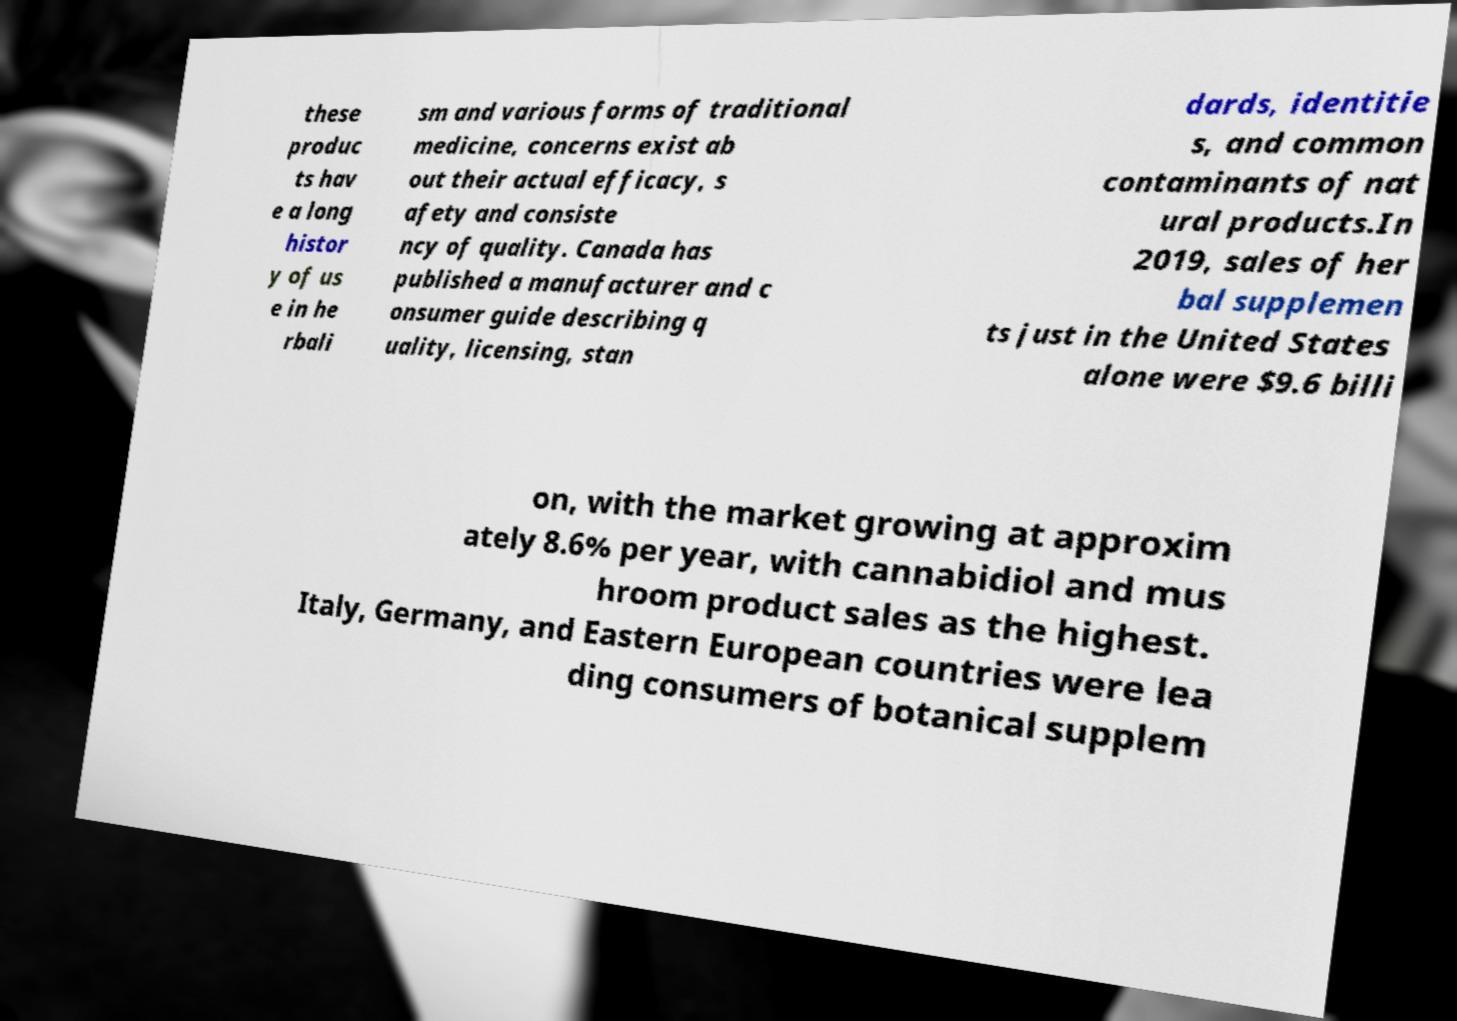What messages or text are displayed in this image? I need them in a readable, typed format. these produc ts hav e a long histor y of us e in he rbali sm and various forms of traditional medicine, concerns exist ab out their actual efficacy, s afety and consiste ncy of quality. Canada has published a manufacturer and c onsumer guide describing q uality, licensing, stan dards, identitie s, and common contaminants of nat ural products.In 2019, sales of her bal supplemen ts just in the United States alone were $9.6 billi on, with the market growing at approxim ately 8.6% per year, with cannabidiol and mus hroom product sales as the highest. Italy, Germany, and Eastern European countries were lea ding consumers of botanical supplem 